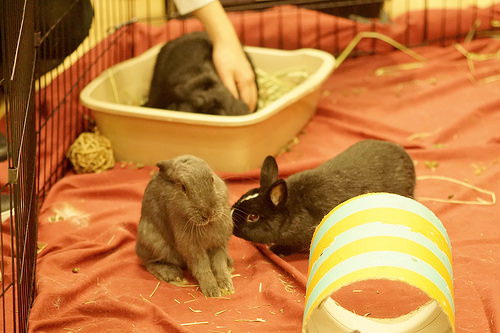<image>
Is the rabbit in the bucket? Yes. The rabbit is contained within or inside the bucket, showing a containment relationship. 